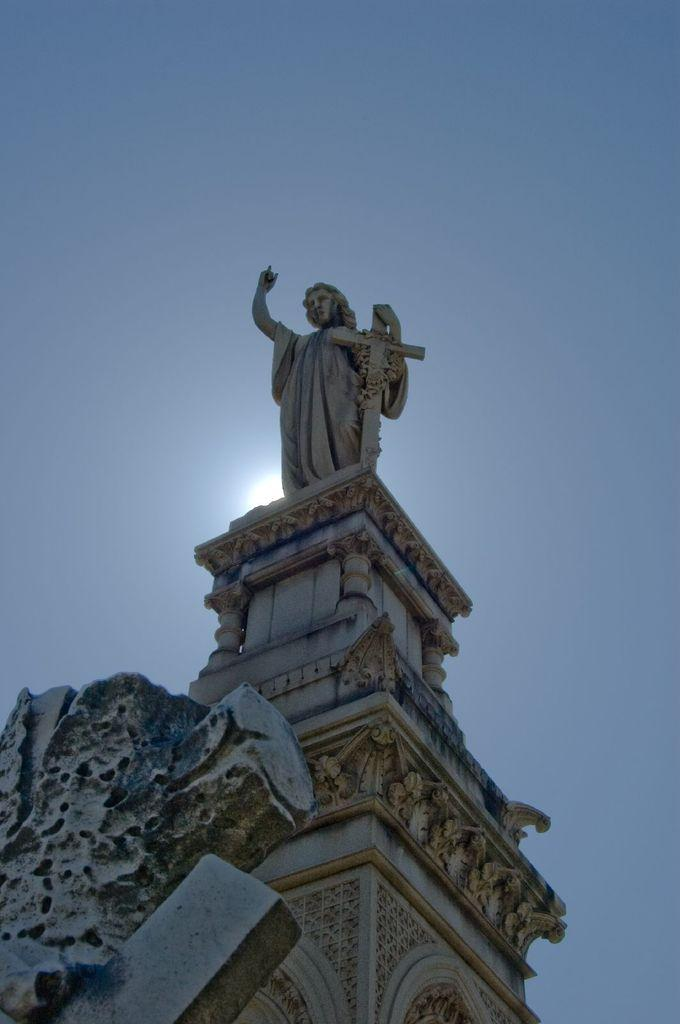What is the main subject of the image? There is a statue in the image. Can you describe the color of the statue? The statue is in white and cream color. What can be seen in the background of the image? The sky is blue and white in color. How many toes does the statue have in the image? The provided facts do not mention the number of toes on the statue, and there is no indication of the statue's feet or toes in the image. 